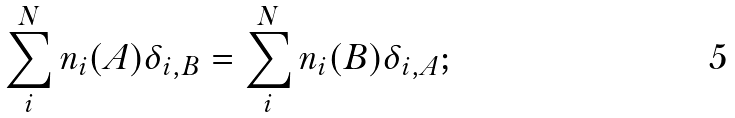Convert formula to latex. <formula><loc_0><loc_0><loc_500><loc_500>\sum _ { i } ^ { N } n _ { i } ( A ) \delta _ { i , B } = \sum _ { i } ^ { N } n _ { i } ( B ) \delta _ { i , A } ;</formula> 